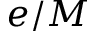<formula> <loc_0><loc_0><loc_500><loc_500>e / M</formula> 